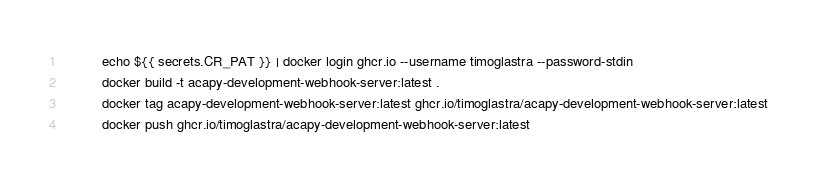<code> <loc_0><loc_0><loc_500><loc_500><_YAML_>          echo ${{ secrets.CR_PAT }} | docker login ghcr.io --username timoglastra --password-stdin
          docker build -t acapy-development-webhook-server:latest .
          docker tag acapy-development-webhook-server:latest ghcr.io/timoglastra/acapy-development-webhook-server:latest
          docker push ghcr.io/timoglastra/acapy-development-webhook-server:latest
</code> 